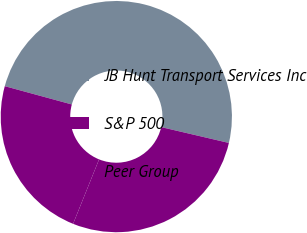<chart> <loc_0><loc_0><loc_500><loc_500><pie_chart><fcel>JB Hunt Transport Services Inc<fcel>S&P 500<fcel>Peer Group<nl><fcel>49.42%<fcel>23.14%<fcel>27.44%<nl></chart> 